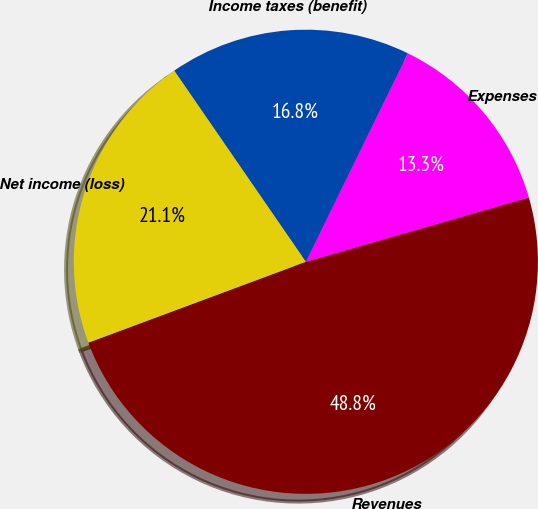<chart> <loc_0><loc_0><loc_500><loc_500><pie_chart><fcel>Revenues<fcel>Expenses<fcel>Income taxes (benefit)<fcel>Net income (loss)<nl><fcel>48.81%<fcel>13.29%<fcel>16.84%<fcel>21.07%<nl></chart> 